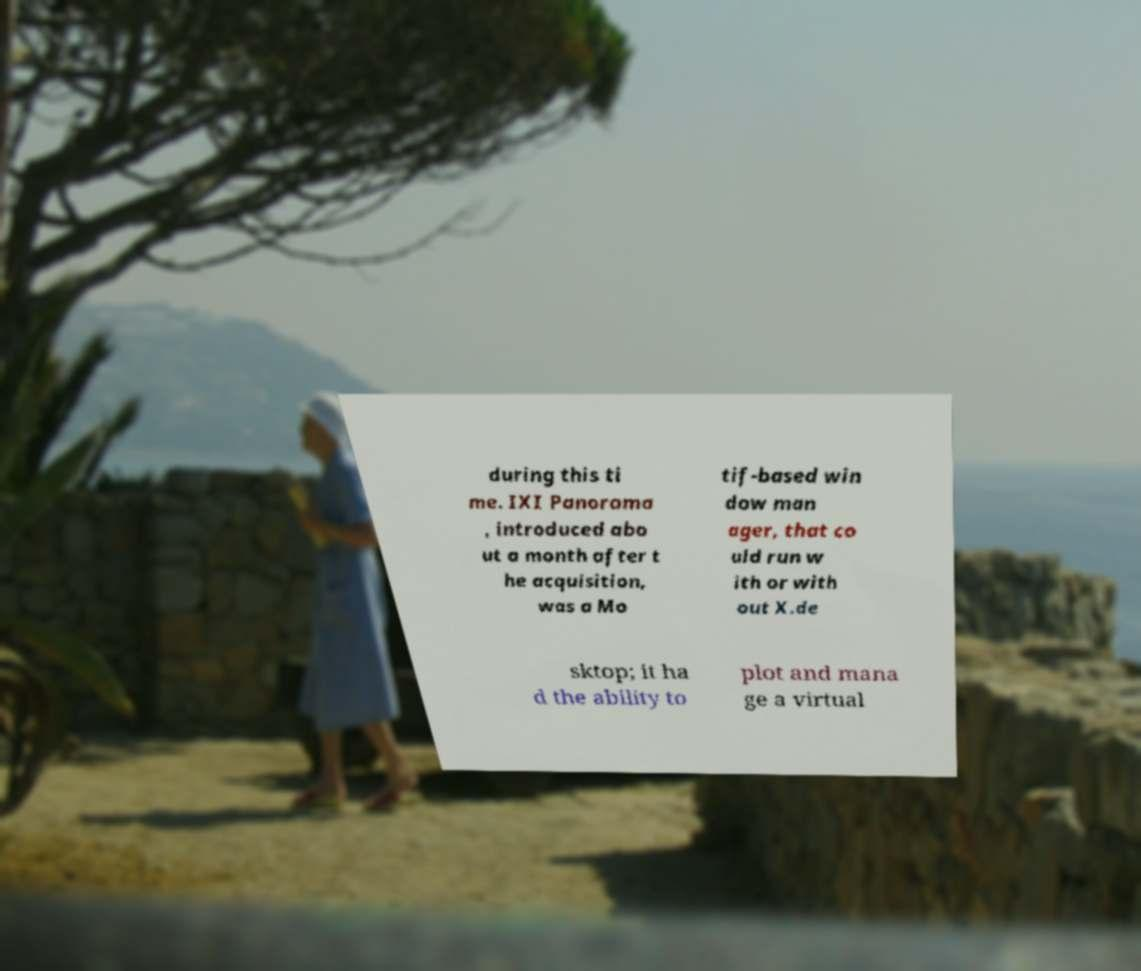Can you read and provide the text displayed in the image?This photo seems to have some interesting text. Can you extract and type it out for me? during this ti me. IXI Panorama , introduced abo ut a month after t he acquisition, was a Mo tif-based win dow man ager, that co uld run w ith or with out X.de sktop; it ha d the ability to plot and mana ge a virtual 